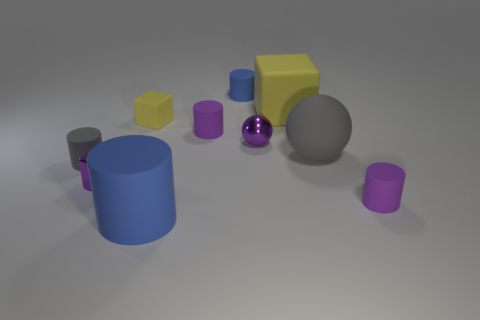There is a large object behind the gray rubber ball; what material is it?
Ensure brevity in your answer.  Rubber. There is a thing behind the large rubber block; does it have the same color as the cylinder that is left of the purple cube?
Provide a succinct answer. No. There is a shiny cube that is the same size as the gray cylinder; what is its color?
Keep it short and to the point. Purple. How many other objects are there of the same shape as the small yellow rubber thing?
Provide a short and direct response. 2. What is the size of the purple rubber object that is in front of the large rubber sphere?
Your answer should be compact. Small. There is a tiny purple rubber thing in front of the big gray matte object; what number of purple metal objects are in front of it?
Provide a succinct answer. 0. What number of other objects are the same size as the purple metal block?
Provide a short and direct response. 6. Is the color of the tiny rubber block the same as the small ball?
Make the answer very short. No. Do the gray object that is left of the large gray object and the big gray rubber thing have the same shape?
Your answer should be compact. No. What number of small purple matte things are both left of the rubber sphere and in front of the tiny shiny sphere?
Offer a very short reply. 0. 